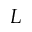<formula> <loc_0><loc_0><loc_500><loc_500>L</formula> 